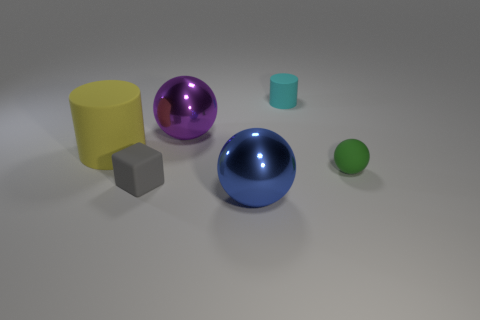Subtract all red cubes. Subtract all gray balls. How many cubes are left? 1 Add 4 cubes. How many objects exist? 10 Subtract all blocks. How many objects are left? 5 Subtract all gray things. Subtract all green spheres. How many objects are left? 4 Add 3 cyan cylinders. How many cyan cylinders are left? 4 Add 2 yellow cylinders. How many yellow cylinders exist? 3 Subtract 0 green blocks. How many objects are left? 6 